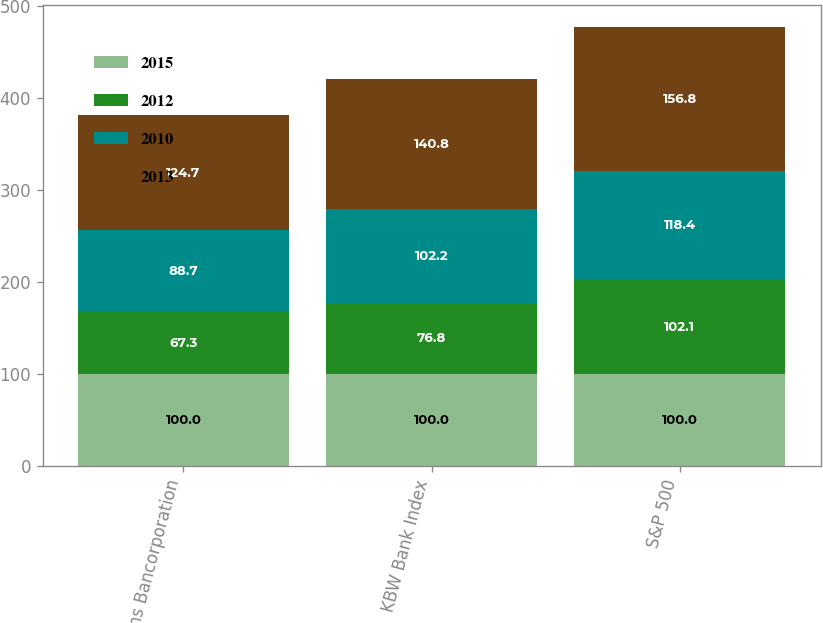Convert chart to OTSL. <chart><loc_0><loc_0><loc_500><loc_500><stacked_bar_chart><ecel><fcel>Zions Bancorporation<fcel>KBW Bank Index<fcel>S&P 500<nl><fcel>2015<fcel>100<fcel>100<fcel>100<nl><fcel>2012<fcel>67.3<fcel>76.8<fcel>102.1<nl><fcel>2010<fcel>88.7<fcel>102.2<fcel>118.4<nl><fcel>2013<fcel>124.7<fcel>140.8<fcel>156.8<nl></chart> 